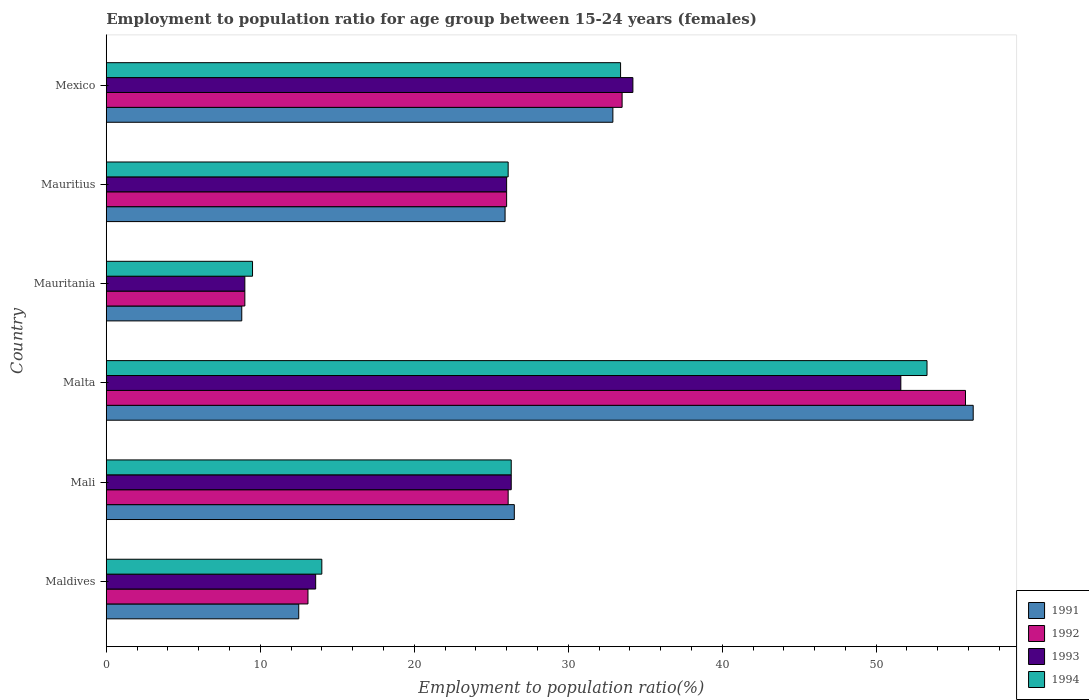How many groups of bars are there?
Make the answer very short. 6. Are the number of bars on each tick of the Y-axis equal?
Provide a short and direct response. Yes. How many bars are there on the 5th tick from the top?
Your answer should be very brief. 4. What is the label of the 2nd group of bars from the top?
Your answer should be compact. Mauritius. In how many cases, is the number of bars for a given country not equal to the number of legend labels?
Your answer should be very brief. 0. What is the employment to population ratio in 1992 in Mexico?
Offer a very short reply. 33.5. Across all countries, what is the maximum employment to population ratio in 1994?
Give a very brief answer. 53.3. In which country was the employment to population ratio in 1994 maximum?
Offer a terse response. Malta. In which country was the employment to population ratio in 1991 minimum?
Give a very brief answer. Mauritania. What is the total employment to population ratio in 1992 in the graph?
Make the answer very short. 163.5. What is the difference between the employment to population ratio in 1991 in Mali and that in Mauritius?
Your response must be concise. 0.6. What is the difference between the employment to population ratio in 1993 in Mali and the employment to population ratio in 1992 in Mexico?
Keep it short and to the point. -7.2. What is the average employment to population ratio in 1992 per country?
Provide a short and direct response. 27.25. What is the difference between the employment to population ratio in 1991 and employment to population ratio in 1994 in Mauritania?
Provide a succinct answer. -0.7. What is the ratio of the employment to population ratio in 1991 in Mauritania to that in Mexico?
Your answer should be very brief. 0.27. Is the difference between the employment to population ratio in 1991 in Mali and Mauritania greater than the difference between the employment to population ratio in 1994 in Mali and Mauritania?
Your answer should be compact. Yes. What is the difference between the highest and the second highest employment to population ratio in 1994?
Offer a terse response. 19.9. What is the difference between the highest and the lowest employment to population ratio in 1991?
Provide a short and direct response. 47.5. Is the sum of the employment to population ratio in 1994 in Mali and Malta greater than the maximum employment to population ratio in 1993 across all countries?
Give a very brief answer. Yes. Is it the case that in every country, the sum of the employment to population ratio in 1993 and employment to population ratio in 1991 is greater than the sum of employment to population ratio in 1994 and employment to population ratio in 1992?
Offer a very short reply. No. Is it the case that in every country, the sum of the employment to population ratio in 1991 and employment to population ratio in 1992 is greater than the employment to population ratio in 1993?
Make the answer very short. Yes. Are all the bars in the graph horizontal?
Give a very brief answer. Yes. What is the difference between two consecutive major ticks on the X-axis?
Provide a short and direct response. 10. Does the graph contain grids?
Give a very brief answer. No. What is the title of the graph?
Keep it short and to the point. Employment to population ratio for age group between 15-24 years (females). What is the label or title of the X-axis?
Your answer should be very brief. Employment to population ratio(%). What is the label or title of the Y-axis?
Your answer should be very brief. Country. What is the Employment to population ratio(%) in 1991 in Maldives?
Provide a short and direct response. 12.5. What is the Employment to population ratio(%) of 1992 in Maldives?
Ensure brevity in your answer.  13.1. What is the Employment to population ratio(%) in 1993 in Maldives?
Your response must be concise. 13.6. What is the Employment to population ratio(%) of 1994 in Maldives?
Provide a short and direct response. 14. What is the Employment to population ratio(%) in 1991 in Mali?
Your answer should be compact. 26.5. What is the Employment to population ratio(%) of 1992 in Mali?
Your answer should be very brief. 26.1. What is the Employment to population ratio(%) in 1993 in Mali?
Provide a short and direct response. 26.3. What is the Employment to population ratio(%) of 1994 in Mali?
Your response must be concise. 26.3. What is the Employment to population ratio(%) in 1991 in Malta?
Offer a terse response. 56.3. What is the Employment to population ratio(%) of 1992 in Malta?
Give a very brief answer. 55.8. What is the Employment to population ratio(%) in 1993 in Malta?
Keep it short and to the point. 51.6. What is the Employment to population ratio(%) of 1994 in Malta?
Offer a terse response. 53.3. What is the Employment to population ratio(%) in 1991 in Mauritania?
Keep it short and to the point. 8.8. What is the Employment to population ratio(%) in 1994 in Mauritania?
Provide a succinct answer. 9.5. What is the Employment to population ratio(%) of 1991 in Mauritius?
Offer a very short reply. 25.9. What is the Employment to population ratio(%) in 1994 in Mauritius?
Offer a terse response. 26.1. What is the Employment to population ratio(%) in 1991 in Mexico?
Make the answer very short. 32.9. What is the Employment to population ratio(%) of 1992 in Mexico?
Offer a terse response. 33.5. What is the Employment to population ratio(%) of 1993 in Mexico?
Your answer should be compact. 34.2. What is the Employment to population ratio(%) in 1994 in Mexico?
Provide a short and direct response. 33.4. Across all countries, what is the maximum Employment to population ratio(%) of 1991?
Make the answer very short. 56.3. Across all countries, what is the maximum Employment to population ratio(%) of 1992?
Offer a terse response. 55.8. Across all countries, what is the maximum Employment to population ratio(%) in 1993?
Offer a very short reply. 51.6. Across all countries, what is the maximum Employment to population ratio(%) in 1994?
Provide a succinct answer. 53.3. Across all countries, what is the minimum Employment to population ratio(%) in 1991?
Provide a succinct answer. 8.8. Across all countries, what is the minimum Employment to population ratio(%) in 1992?
Keep it short and to the point. 9. Across all countries, what is the minimum Employment to population ratio(%) of 1994?
Offer a terse response. 9.5. What is the total Employment to population ratio(%) in 1991 in the graph?
Your answer should be compact. 162.9. What is the total Employment to population ratio(%) in 1992 in the graph?
Ensure brevity in your answer.  163.5. What is the total Employment to population ratio(%) of 1993 in the graph?
Offer a terse response. 160.7. What is the total Employment to population ratio(%) in 1994 in the graph?
Your response must be concise. 162.6. What is the difference between the Employment to population ratio(%) in 1992 in Maldives and that in Mali?
Your answer should be compact. -13. What is the difference between the Employment to population ratio(%) of 1993 in Maldives and that in Mali?
Your answer should be very brief. -12.7. What is the difference between the Employment to population ratio(%) in 1994 in Maldives and that in Mali?
Keep it short and to the point. -12.3. What is the difference between the Employment to population ratio(%) of 1991 in Maldives and that in Malta?
Offer a terse response. -43.8. What is the difference between the Employment to population ratio(%) of 1992 in Maldives and that in Malta?
Your response must be concise. -42.7. What is the difference between the Employment to population ratio(%) of 1993 in Maldives and that in Malta?
Give a very brief answer. -38. What is the difference between the Employment to population ratio(%) in 1994 in Maldives and that in Malta?
Ensure brevity in your answer.  -39.3. What is the difference between the Employment to population ratio(%) of 1992 in Maldives and that in Mauritania?
Your response must be concise. 4.1. What is the difference between the Employment to population ratio(%) in 1993 in Maldives and that in Mauritania?
Offer a terse response. 4.6. What is the difference between the Employment to population ratio(%) in 1991 in Maldives and that in Mauritius?
Offer a very short reply. -13.4. What is the difference between the Employment to population ratio(%) in 1992 in Maldives and that in Mauritius?
Offer a very short reply. -12.9. What is the difference between the Employment to population ratio(%) of 1991 in Maldives and that in Mexico?
Your answer should be compact. -20.4. What is the difference between the Employment to population ratio(%) of 1992 in Maldives and that in Mexico?
Keep it short and to the point. -20.4. What is the difference between the Employment to population ratio(%) in 1993 in Maldives and that in Mexico?
Give a very brief answer. -20.6. What is the difference between the Employment to population ratio(%) in 1994 in Maldives and that in Mexico?
Your answer should be compact. -19.4. What is the difference between the Employment to population ratio(%) of 1991 in Mali and that in Malta?
Your answer should be very brief. -29.8. What is the difference between the Employment to population ratio(%) of 1992 in Mali and that in Malta?
Your response must be concise. -29.7. What is the difference between the Employment to population ratio(%) in 1993 in Mali and that in Malta?
Give a very brief answer. -25.3. What is the difference between the Employment to population ratio(%) of 1991 in Mali and that in Mauritania?
Offer a very short reply. 17.7. What is the difference between the Employment to population ratio(%) in 1993 in Mali and that in Mauritania?
Make the answer very short. 17.3. What is the difference between the Employment to population ratio(%) in 1991 in Mali and that in Mauritius?
Keep it short and to the point. 0.6. What is the difference between the Employment to population ratio(%) of 1992 in Mali and that in Mauritius?
Provide a succinct answer. 0.1. What is the difference between the Employment to population ratio(%) of 1993 in Mali and that in Mauritius?
Keep it short and to the point. 0.3. What is the difference between the Employment to population ratio(%) of 1994 in Mali and that in Mauritius?
Give a very brief answer. 0.2. What is the difference between the Employment to population ratio(%) in 1991 in Mali and that in Mexico?
Give a very brief answer. -6.4. What is the difference between the Employment to population ratio(%) in 1992 in Mali and that in Mexico?
Offer a terse response. -7.4. What is the difference between the Employment to population ratio(%) of 1991 in Malta and that in Mauritania?
Make the answer very short. 47.5. What is the difference between the Employment to population ratio(%) in 1992 in Malta and that in Mauritania?
Give a very brief answer. 46.8. What is the difference between the Employment to population ratio(%) of 1993 in Malta and that in Mauritania?
Give a very brief answer. 42.6. What is the difference between the Employment to population ratio(%) of 1994 in Malta and that in Mauritania?
Offer a very short reply. 43.8. What is the difference between the Employment to population ratio(%) of 1991 in Malta and that in Mauritius?
Your response must be concise. 30.4. What is the difference between the Employment to population ratio(%) in 1992 in Malta and that in Mauritius?
Your answer should be compact. 29.8. What is the difference between the Employment to population ratio(%) of 1993 in Malta and that in Mauritius?
Provide a succinct answer. 25.6. What is the difference between the Employment to population ratio(%) of 1994 in Malta and that in Mauritius?
Keep it short and to the point. 27.2. What is the difference between the Employment to population ratio(%) in 1991 in Malta and that in Mexico?
Give a very brief answer. 23.4. What is the difference between the Employment to population ratio(%) in 1992 in Malta and that in Mexico?
Your response must be concise. 22.3. What is the difference between the Employment to population ratio(%) of 1994 in Malta and that in Mexico?
Give a very brief answer. 19.9. What is the difference between the Employment to population ratio(%) in 1991 in Mauritania and that in Mauritius?
Provide a short and direct response. -17.1. What is the difference between the Employment to population ratio(%) of 1994 in Mauritania and that in Mauritius?
Provide a succinct answer. -16.6. What is the difference between the Employment to population ratio(%) in 1991 in Mauritania and that in Mexico?
Your answer should be very brief. -24.1. What is the difference between the Employment to population ratio(%) of 1992 in Mauritania and that in Mexico?
Your response must be concise. -24.5. What is the difference between the Employment to population ratio(%) in 1993 in Mauritania and that in Mexico?
Your answer should be very brief. -25.2. What is the difference between the Employment to population ratio(%) of 1994 in Mauritania and that in Mexico?
Keep it short and to the point. -23.9. What is the difference between the Employment to population ratio(%) in 1993 in Mauritius and that in Mexico?
Your answer should be very brief. -8.2. What is the difference between the Employment to population ratio(%) in 1994 in Mauritius and that in Mexico?
Your response must be concise. -7.3. What is the difference between the Employment to population ratio(%) of 1991 in Maldives and the Employment to population ratio(%) of 1992 in Mali?
Provide a succinct answer. -13.6. What is the difference between the Employment to population ratio(%) of 1992 in Maldives and the Employment to population ratio(%) of 1993 in Mali?
Offer a terse response. -13.2. What is the difference between the Employment to population ratio(%) in 1991 in Maldives and the Employment to population ratio(%) in 1992 in Malta?
Provide a short and direct response. -43.3. What is the difference between the Employment to population ratio(%) in 1991 in Maldives and the Employment to population ratio(%) in 1993 in Malta?
Provide a succinct answer. -39.1. What is the difference between the Employment to population ratio(%) of 1991 in Maldives and the Employment to population ratio(%) of 1994 in Malta?
Make the answer very short. -40.8. What is the difference between the Employment to population ratio(%) in 1992 in Maldives and the Employment to population ratio(%) in 1993 in Malta?
Make the answer very short. -38.5. What is the difference between the Employment to population ratio(%) in 1992 in Maldives and the Employment to population ratio(%) in 1994 in Malta?
Your answer should be compact. -40.2. What is the difference between the Employment to population ratio(%) in 1993 in Maldives and the Employment to population ratio(%) in 1994 in Malta?
Your answer should be compact. -39.7. What is the difference between the Employment to population ratio(%) in 1992 in Maldives and the Employment to population ratio(%) in 1994 in Mauritania?
Keep it short and to the point. 3.6. What is the difference between the Employment to population ratio(%) of 1991 in Maldives and the Employment to population ratio(%) of 1993 in Mauritius?
Keep it short and to the point. -13.5. What is the difference between the Employment to population ratio(%) in 1992 in Maldives and the Employment to population ratio(%) in 1994 in Mauritius?
Your answer should be very brief. -13. What is the difference between the Employment to population ratio(%) in 1991 in Maldives and the Employment to population ratio(%) in 1992 in Mexico?
Give a very brief answer. -21. What is the difference between the Employment to population ratio(%) of 1991 in Maldives and the Employment to population ratio(%) of 1993 in Mexico?
Your response must be concise. -21.7. What is the difference between the Employment to population ratio(%) in 1991 in Maldives and the Employment to population ratio(%) in 1994 in Mexico?
Your answer should be very brief. -20.9. What is the difference between the Employment to population ratio(%) of 1992 in Maldives and the Employment to population ratio(%) of 1993 in Mexico?
Your answer should be compact. -21.1. What is the difference between the Employment to population ratio(%) in 1992 in Maldives and the Employment to population ratio(%) in 1994 in Mexico?
Provide a short and direct response. -20.3. What is the difference between the Employment to population ratio(%) of 1993 in Maldives and the Employment to population ratio(%) of 1994 in Mexico?
Keep it short and to the point. -19.8. What is the difference between the Employment to population ratio(%) in 1991 in Mali and the Employment to population ratio(%) in 1992 in Malta?
Provide a succinct answer. -29.3. What is the difference between the Employment to population ratio(%) in 1991 in Mali and the Employment to population ratio(%) in 1993 in Malta?
Provide a short and direct response. -25.1. What is the difference between the Employment to population ratio(%) of 1991 in Mali and the Employment to population ratio(%) of 1994 in Malta?
Offer a very short reply. -26.8. What is the difference between the Employment to population ratio(%) in 1992 in Mali and the Employment to population ratio(%) in 1993 in Malta?
Ensure brevity in your answer.  -25.5. What is the difference between the Employment to population ratio(%) of 1992 in Mali and the Employment to population ratio(%) of 1994 in Malta?
Ensure brevity in your answer.  -27.2. What is the difference between the Employment to population ratio(%) in 1991 in Mali and the Employment to population ratio(%) in 1993 in Mauritania?
Your answer should be compact. 17.5. What is the difference between the Employment to population ratio(%) of 1991 in Mali and the Employment to population ratio(%) of 1994 in Mauritania?
Offer a terse response. 17. What is the difference between the Employment to population ratio(%) in 1992 in Mali and the Employment to population ratio(%) in 1993 in Mauritania?
Your response must be concise. 17.1. What is the difference between the Employment to population ratio(%) in 1992 in Mali and the Employment to population ratio(%) in 1994 in Mauritania?
Give a very brief answer. 16.6. What is the difference between the Employment to population ratio(%) in 1993 in Mali and the Employment to population ratio(%) in 1994 in Mauritania?
Your response must be concise. 16.8. What is the difference between the Employment to population ratio(%) in 1991 in Mali and the Employment to population ratio(%) in 1993 in Mauritius?
Ensure brevity in your answer.  0.5. What is the difference between the Employment to population ratio(%) of 1993 in Mali and the Employment to population ratio(%) of 1994 in Mauritius?
Your response must be concise. 0.2. What is the difference between the Employment to population ratio(%) of 1991 in Mali and the Employment to population ratio(%) of 1994 in Mexico?
Give a very brief answer. -6.9. What is the difference between the Employment to population ratio(%) of 1992 in Mali and the Employment to population ratio(%) of 1993 in Mexico?
Your answer should be compact. -8.1. What is the difference between the Employment to population ratio(%) of 1991 in Malta and the Employment to population ratio(%) of 1992 in Mauritania?
Keep it short and to the point. 47.3. What is the difference between the Employment to population ratio(%) of 1991 in Malta and the Employment to population ratio(%) of 1993 in Mauritania?
Ensure brevity in your answer.  47.3. What is the difference between the Employment to population ratio(%) in 1991 in Malta and the Employment to population ratio(%) in 1994 in Mauritania?
Your answer should be compact. 46.8. What is the difference between the Employment to population ratio(%) in 1992 in Malta and the Employment to population ratio(%) in 1993 in Mauritania?
Give a very brief answer. 46.8. What is the difference between the Employment to population ratio(%) in 1992 in Malta and the Employment to population ratio(%) in 1994 in Mauritania?
Offer a terse response. 46.3. What is the difference between the Employment to population ratio(%) in 1993 in Malta and the Employment to population ratio(%) in 1994 in Mauritania?
Give a very brief answer. 42.1. What is the difference between the Employment to population ratio(%) in 1991 in Malta and the Employment to population ratio(%) in 1992 in Mauritius?
Provide a succinct answer. 30.3. What is the difference between the Employment to population ratio(%) of 1991 in Malta and the Employment to population ratio(%) of 1993 in Mauritius?
Keep it short and to the point. 30.3. What is the difference between the Employment to population ratio(%) in 1991 in Malta and the Employment to population ratio(%) in 1994 in Mauritius?
Ensure brevity in your answer.  30.2. What is the difference between the Employment to population ratio(%) of 1992 in Malta and the Employment to population ratio(%) of 1993 in Mauritius?
Provide a succinct answer. 29.8. What is the difference between the Employment to population ratio(%) in 1992 in Malta and the Employment to population ratio(%) in 1994 in Mauritius?
Your answer should be very brief. 29.7. What is the difference between the Employment to population ratio(%) of 1991 in Malta and the Employment to population ratio(%) of 1992 in Mexico?
Give a very brief answer. 22.8. What is the difference between the Employment to population ratio(%) in 1991 in Malta and the Employment to population ratio(%) in 1993 in Mexico?
Ensure brevity in your answer.  22.1. What is the difference between the Employment to population ratio(%) of 1991 in Malta and the Employment to population ratio(%) of 1994 in Mexico?
Your response must be concise. 22.9. What is the difference between the Employment to population ratio(%) in 1992 in Malta and the Employment to population ratio(%) in 1993 in Mexico?
Your answer should be very brief. 21.6. What is the difference between the Employment to population ratio(%) in 1992 in Malta and the Employment to population ratio(%) in 1994 in Mexico?
Provide a short and direct response. 22.4. What is the difference between the Employment to population ratio(%) of 1991 in Mauritania and the Employment to population ratio(%) of 1992 in Mauritius?
Ensure brevity in your answer.  -17.2. What is the difference between the Employment to population ratio(%) of 1991 in Mauritania and the Employment to population ratio(%) of 1993 in Mauritius?
Provide a succinct answer. -17.2. What is the difference between the Employment to population ratio(%) in 1991 in Mauritania and the Employment to population ratio(%) in 1994 in Mauritius?
Offer a terse response. -17.3. What is the difference between the Employment to population ratio(%) of 1992 in Mauritania and the Employment to population ratio(%) of 1994 in Mauritius?
Make the answer very short. -17.1. What is the difference between the Employment to population ratio(%) of 1993 in Mauritania and the Employment to population ratio(%) of 1994 in Mauritius?
Offer a terse response. -17.1. What is the difference between the Employment to population ratio(%) in 1991 in Mauritania and the Employment to population ratio(%) in 1992 in Mexico?
Make the answer very short. -24.7. What is the difference between the Employment to population ratio(%) in 1991 in Mauritania and the Employment to population ratio(%) in 1993 in Mexico?
Your answer should be very brief. -25.4. What is the difference between the Employment to population ratio(%) of 1991 in Mauritania and the Employment to population ratio(%) of 1994 in Mexico?
Provide a short and direct response. -24.6. What is the difference between the Employment to population ratio(%) in 1992 in Mauritania and the Employment to population ratio(%) in 1993 in Mexico?
Make the answer very short. -25.2. What is the difference between the Employment to population ratio(%) of 1992 in Mauritania and the Employment to population ratio(%) of 1994 in Mexico?
Keep it short and to the point. -24.4. What is the difference between the Employment to population ratio(%) in 1993 in Mauritania and the Employment to population ratio(%) in 1994 in Mexico?
Your answer should be very brief. -24.4. What is the difference between the Employment to population ratio(%) of 1991 in Mauritius and the Employment to population ratio(%) of 1993 in Mexico?
Offer a very short reply. -8.3. What is the difference between the Employment to population ratio(%) in 1992 in Mauritius and the Employment to population ratio(%) in 1993 in Mexico?
Your response must be concise. -8.2. What is the difference between the Employment to population ratio(%) of 1992 in Mauritius and the Employment to population ratio(%) of 1994 in Mexico?
Your answer should be very brief. -7.4. What is the difference between the Employment to population ratio(%) in 1993 in Mauritius and the Employment to population ratio(%) in 1994 in Mexico?
Your answer should be very brief. -7.4. What is the average Employment to population ratio(%) in 1991 per country?
Make the answer very short. 27.15. What is the average Employment to population ratio(%) in 1992 per country?
Give a very brief answer. 27.25. What is the average Employment to population ratio(%) of 1993 per country?
Provide a short and direct response. 26.78. What is the average Employment to population ratio(%) of 1994 per country?
Keep it short and to the point. 27.1. What is the difference between the Employment to population ratio(%) in 1991 and Employment to population ratio(%) in 1993 in Maldives?
Offer a very short reply. -1.1. What is the difference between the Employment to population ratio(%) in 1991 and Employment to population ratio(%) in 1994 in Maldives?
Provide a succinct answer. -1.5. What is the difference between the Employment to population ratio(%) in 1992 and Employment to population ratio(%) in 1994 in Maldives?
Make the answer very short. -0.9. What is the difference between the Employment to population ratio(%) in 1991 and Employment to population ratio(%) in 1993 in Mali?
Make the answer very short. 0.2. What is the difference between the Employment to population ratio(%) in 1992 and Employment to population ratio(%) in 1994 in Mali?
Offer a very short reply. -0.2. What is the difference between the Employment to population ratio(%) in 1991 and Employment to population ratio(%) in 1992 in Malta?
Your response must be concise. 0.5. What is the difference between the Employment to population ratio(%) in 1991 and Employment to population ratio(%) in 1993 in Malta?
Offer a terse response. 4.7. What is the difference between the Employment to population ratio(%) of 1991 and Employment to population ratio(%) of 1994 in Malta?
Offer a terse response. 3. What is the difference between the Employment to population ratio(%) in 1992 and Employment to population ratio(%) in 1993 in Malta?
Your response must be concise. 4.2. What is the difference between the Employment to population ratio(%) of 1992 and Employment to population ratio(%) of 1994 in Malta?
Your response must be concise. 2.5. What is the difference between the Employment to population ratio(%) of 1992 and Employment to population ratio(%) of 1993 in Mauritania?
Your answer should be compact. 0. What is the difference between the Employment to population ratio(%) in 1992 and Employment to population ratio(%) in 1994 in Mauritania?
Provide a short and direct response. -0.5. What is the difference between the Employment to population ratio(%) in 1991 and Employment to population ratio(%) in 1992 in Mauritius?
Give a very brief answer. -0.1. What is the difference between the Employment to population ratio(%) in 1991 and Employment to population ratio(%) in 1993 in Mauritius?
Ensure brevity in your answer.  -0.1. What is the difference between the Employment to population ratio(%) of 1991 and Employment to population ratio(%) of 1994 in Mauritius?
Give a very brief answer. -0.2. What is the difference between the Employment to population ratio(%) in 1992 and Employment to population ratio(%) in 1993 in Mauritius?
Your response must be concise. 0. What is the difference between the Employment to population ratio(%) in 1992 and Employment to population ratio(%) in 1994 in Mauritius?
Offer a terse response. -0.1. What is the difference between the Employment to population ratio(%) in 1991 and Employment to population ratio(%) in 1992 in Mexico?
Ensure brevity in your answer.  -0.6. What is the difference between the Employment to population ratio(%) of 1992 and Employment to population ratio(%) of 1993 in Mexico?
Make the answer very short. -0.7. What is the difference between the Employment to population ratio(%) in 1992 and Employment to population ratio(%) in 1994 in Mexico?
Give a very brief answer. 0.1. What is the difference between the Employment to population ratio(%) of 1993 and Employment to population ratio(%) of 1994 in Mexico?
Provide a short and direct response. 0.8. What is the ratio of the Employment to population ratio(%) in 1991 in Maldives to that in Mali?
Give a very brief answer. 0.47. What is the ratio of the Employment to population ratio(%) in 1992 in Maldives to that in Mali?
Ensure brevity in your answer.  0.5. What is the ratio of the Employment to population ratio(%) of 1993 in Maldives to that in Mali?
Ensure brevity in your answer.  0.52. What is the ratio of the Employment to population ratio(%) of 1994 in Maldives to that in Mali?
Give a very brief answer. 0.53. What is the ratio of the Employment to population ratio(%) of 1991 in Maldives to that in Malta?
Offer a terse response. 0.22. What is the ratio of the Employment to population ratio(%) in 1992 in Maldives to that in Malta?
Give a very brief answer. 0.23. What is the ratio of the Employment to population ratio(%) of 1993 in Maldives to that in Malta?
Make the answer very short. 0.26. What is the ratio of the Employment to population ratio(%) in 1994 in Maldives to that in Malta?
Keep it short and to the point. 0.26. What is the ratio of the Employment to population ratio(%) of 1991 in Maldives to that in Mauritania?
Give a very brief answer. 1.42. What is the ratio of the Employment to population ratio(%) of 1992 in Maldives to that in Mauritania?
Offer a terse response. 1.46. What is the ratio of the Employment to population ratio(%) in 1993 in Maldives to that in Mauritania?
Offer a terse response. 1.51. What is the ratio of the Employment to population ratio(%) of 1994 in Maldives to that in Mauritania?
Make the answer very short. 1.47. What is the ratio of the Employment to population ratio(%) in 1991 in Maldives to that in Mauritius?
Provide a short and direct response. 0.48. What is the ratio of the Employment to population ratio(%) of 1992 in Maldives to that in Mauritius?
Provide a succinct answer. 0.5. What is the ratio of the Employment to population ratio(%) of 1993 in Maldives to that in Mauritius?
Give a very brief answer. 0.52. What is the ratio of the Employment to population ratio(%) of 1994 in Maldives to that in Mauritius?
Make the answer very short. 0.54. What is the ratio of the Employment to population ratio(%) in 1991 in Maldives to that in Mexico?
Make the answer very short. 0.38. What is the ratio of the Employment to population ratio(%) of 1992 in Maldives to that in Mexico?
Offer a very short reply. 0.39. What is the ratio of the Employment to population ratio(%) in 1993 in Maldives to that in Mexico?
Offer a terse response. 0.4. What is the ratio of the Employment to population ratio(%) in 1994 in Maldives to that in Mexico?
Ensure brevity in your answer.  0.42. What is the ratio of the Employment to population ratio(%) of 1991 in Mali to that in Malta?
Keep it short and to the point. 0.47. What is the ratio of the Employment to population ratio(%) in 1992 in Mali to that in Malta?
Your answer should be very brief. 0.47. What is the ratio of the Employment to population ratio(%) in 1993 in Mali to that in Malta?
Your response must be concise. 0.51. What is the ratio of the Employment to population ratio(%) in 1994 in Mali to that in Malta?
Offer a terse response. 0.49. What is the ratio of the Employment to population ratio(%) of 1991 in Mali to that in Mauritania?
Make the answer very short. 3.01. What is the ratio of the Employment to population ratio(%) in 1993 in Mali to that in Mauritania?
Your answer should be very brief. 2.92. What is the ratio of the Employment to population ratio(%) of 1994 in Mali to that in Mauritania?
Your response must be concise. 2.77. What is the ratio of the Employment to population ratio(%) of 1991 in Mali to that in Mauritius?
Keep it short and to the point. 1.02. What is the ratio of the Employment to population ratio(%) of 1992 in Mali to that in Mauritius?
Your answer should be compact. 1. What is the ratio of the Employment to population ratio(%) in 1993 in Mali to that in Mauritius?
Provide a short and direct response. 1.01. What is the ratio of the Employment to population ratio(%) in 1994 in Mali to that in Mauritius?
Ensure brevity in your answer.  1.01. What is the ratio of the Employment to population ratio(%) of 1991 in Mali to that in Mexico?
Your response must be concise. 0.81. What is the ratio of the Employment to population ratio(%) in 1992 in Mali to that in Mexico?
Keep it short and to the point. 0.78. What is the ratio of the Employment to population ratio(%) of 1993 in Mali to that in Mexico?
Your answer should be compact. 0.77. What is the ratio of the Employment to population ratio(%) in 1994 in Mali to that in Mexico?
Provide a succinct answer. 0.79. What is the ratio of the Employment to population ratio(%) in 1991 in Malta to that in Mauritania?
Your answer should be very brief. 6.4. What is the ratio of the Employment to population ratio(%) of 1992 in Malta to that in Mauritania?
Your answer should be compact. 6.2. What is the ratio of the Employment to population ratio(%) in 1993 in Malta to that in Mauritania?
Give a very brief answer. 5.73. What is the ratio of the Employment to population ratio(%) in 1994 in Malta to that in Mauritania?
Provide a succinct answer. 5.61. What is the ratio of the Employment to population ratio(%) in 1991 in Malta to that in Mauritius?
Your response must be concise. 2.17. What is the ratio of the Employment to population ratio(%) of 1992 in Malta to that in Mauritius?
Provide a succinct answer. 2.15. What is the ratio of the Employment to population ratio(%) in 1993 in Malta to that in Mauritius?
Give a very brief answer. 1.98. What is the ratio of the Employment to population ratio(%) of 1994 in Malta to that in Mauritius?
Keep it short and to the point. 2.04. What is the ratio of the Employment to population ratio(%) of 1991 in Malta to that in Mexico?
Your answer should be compact. 1.71. What is the ratio of the Employment to population ratio(%) of 1992 in Malta to that in Mexico?
Your answer should be very brief. 1.67. What is the ratio of the Employment to population ratio(%) of 1993 in Malta to that in Mexico?
Give a very brief answer. 1.51. What is the ratio of the Employment to population ratio(%) of 1994 in Malta to that in Mexico?
Make the answer very short. 1.6. What is the ratio of the Employment to population ratio(%) of 1991 in Mauritania to that in Mauritius?
Make the answer very short. 0.34. What is the ratio of the Employment to population ratio(%) of 1992 in Mauritania to that in Mauritius?
Your answer should be very brief. 0.35. What is the ratio of the Employment to population ratio(%) in 1993 in Mauritania to that in Mauritius?
Offer a terse response. 0.35. What is the ratio of the Employment to population ratio(%) in 1994 in Mauritania to that in Mauritius?
Make the answer very short. 0.36. What is the ratio of the Employment to population ratio(%) in 1991 in Mauritania to that in Mexico?
Provide a succinct answer. 0.27. What is the ratio of the Employment to population ratio(%) in 1992 in Mauritania to that in Mexico?
Ensure brevity in your answer.  0.27. What is the ratio of the Employment to population ratio(%) of 1993 in Mauritania to that in Mexico?
Offer a terse response. 0.26. What is the ratio of the Employment to population ratio(%) of 1994 in Mauritania to that in Mexico?
Provide a short and direct response. 0.28. What is the ratio of the Employment to population ratio(%) in 1991 in Mauritius to that in Mexico?
Your answer should be very brief. 0.79. What is the ratio of the Employment to population ratio(%) of 1992 in Mauritius to that in Mexico?
Provide a succinct answer. 0.78. What is the ratio of the Employment to population ratio(%) of 1993 in Mauritius to that in Mexico?
Make the answer very short. 0.76. What is the ratio of the Employment to population ratio(%) in 1994 in Mauritius to that in Mexico?
Your answer should be very brief. 0.78. What is the difference between the highest and the second highest Employment to population ratio(%) in 1991?
Your answer should be compact. 23.4. What is the difference between the highest and the second highest Employment to population ratio(%) of 1992?
Offer a terse response. 22.3. What is the difference between the highest and the second highest Employment to population ratio(%) of 1993?
Your answer should be compact. 17.4. What is the difference between the highest and the second highest Employment to population ratio(%) of 1994?
Provide a succinct answer. 19.9. What is the difference between the highest and the lowest Employment to population ratio(%) of 1991?
Give a very brief answer. 47.5. What is the difference between the highest and the lowest Employment to population ratio(%) in 1992?
Offer a terse response. 46.8. What is the difference between the highest and the lowest Employment to population ratio(%) in 1993?
Offer a very short reply. 42.6. What is the difference between the highest and the lowest Employment to population ratio(%) of 1994?
Provide a short and direct response. 43.8. 